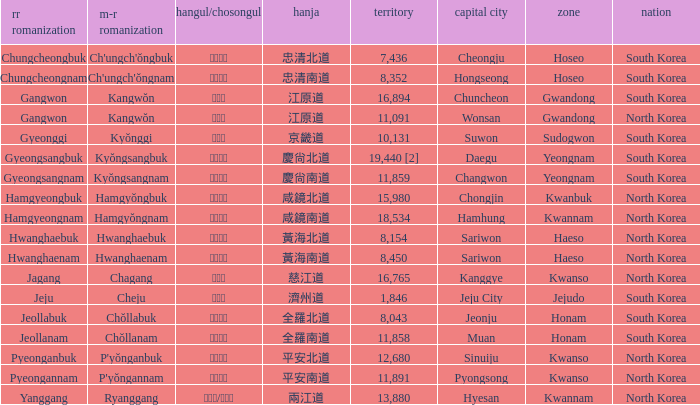Which capital has a Hangul of 경상남도? Changwon. 